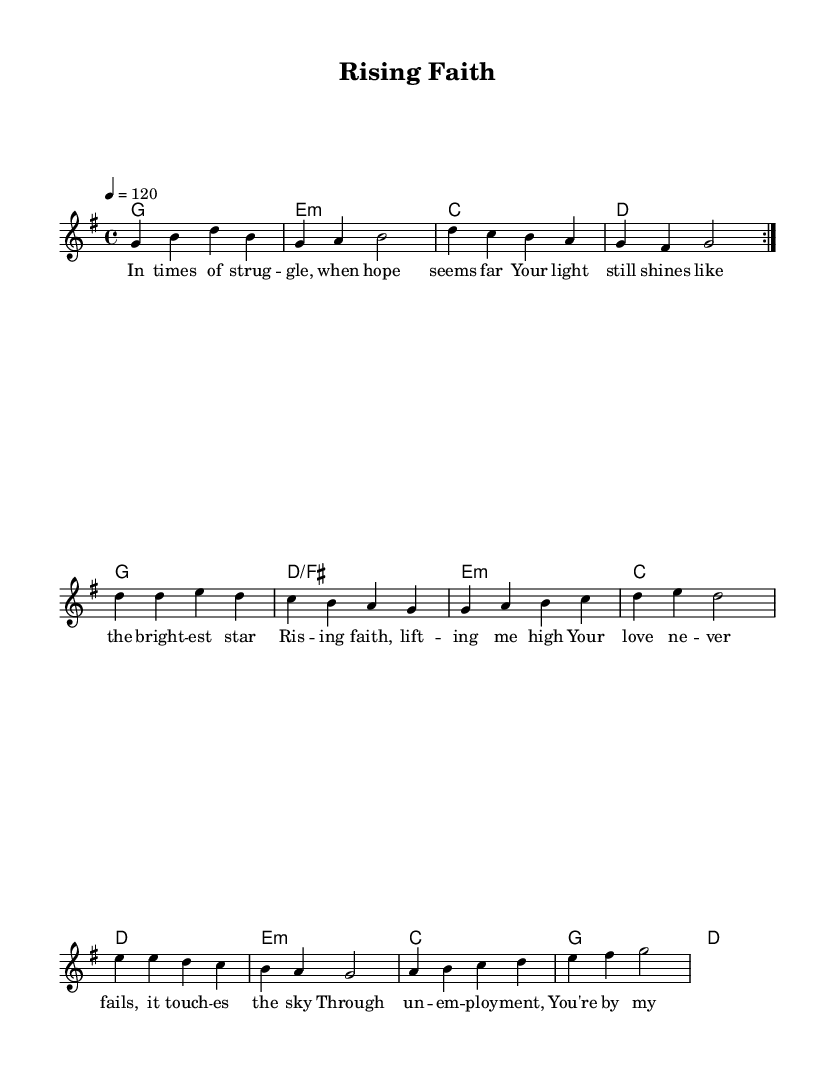What is the key signature of this music? The key signature is indicated by the presence of one sharp (F#) in the piece. This is characteristic of G major.
Answer: G major What is the time signature of this music? The time signature is shown at the beginning of the piece as 4/4, which means there are four beats per measure.
Answer: 4/4 What is the tempo marking in this music? The tempo marking indicates that the piece is played at a speed of 120 beats per minute.
Answer: 120 How many verses are in the song? The song consists of two verses as indicated by the lyrics labeled "verseOne" and "verseTwo".
Answer: Two What chord appears at the start of the second verse? The chord at the start of the second verse is E minor, as indicated in the harmony line corresponding to that part.
Answer: E minor What lyric follows "Your love never fails"? The next lyric that follows is "it touches the sky", as shown in the chorus section right after that line.
Answer: it touches the sky Which section of the song contains the word "struggle"? The word "struggle" appears in "verseOne", as indicated in the lyric line where that verse is notated.
Answer: verseOne 